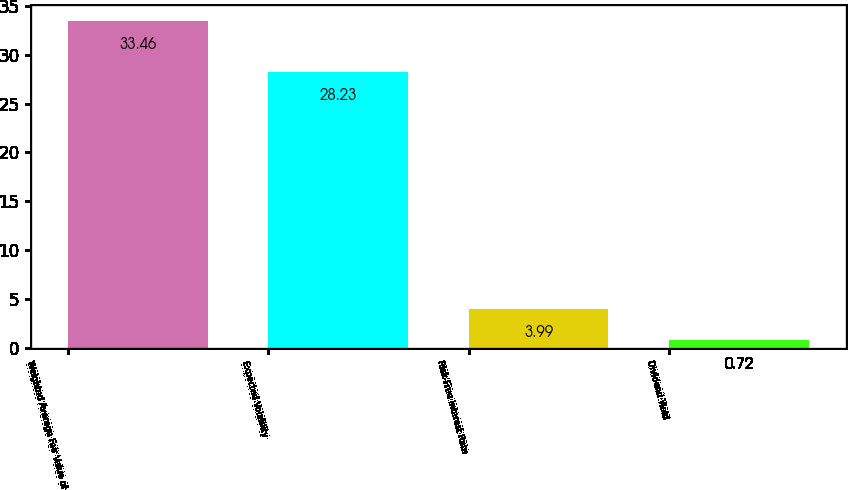Convert chart. <chart><loc_0><loc_0><loc_500><loc_500><bar_chart><fcel>Weighted Average Fair Value of<fcel>Expected Volatility<fcel>Risk-Free Interest Rate<fcel>Dividend Yield<nl><fcel>33.46<fcel>28.23<fcel>3.99<fcel>0.72<nl></chart> 